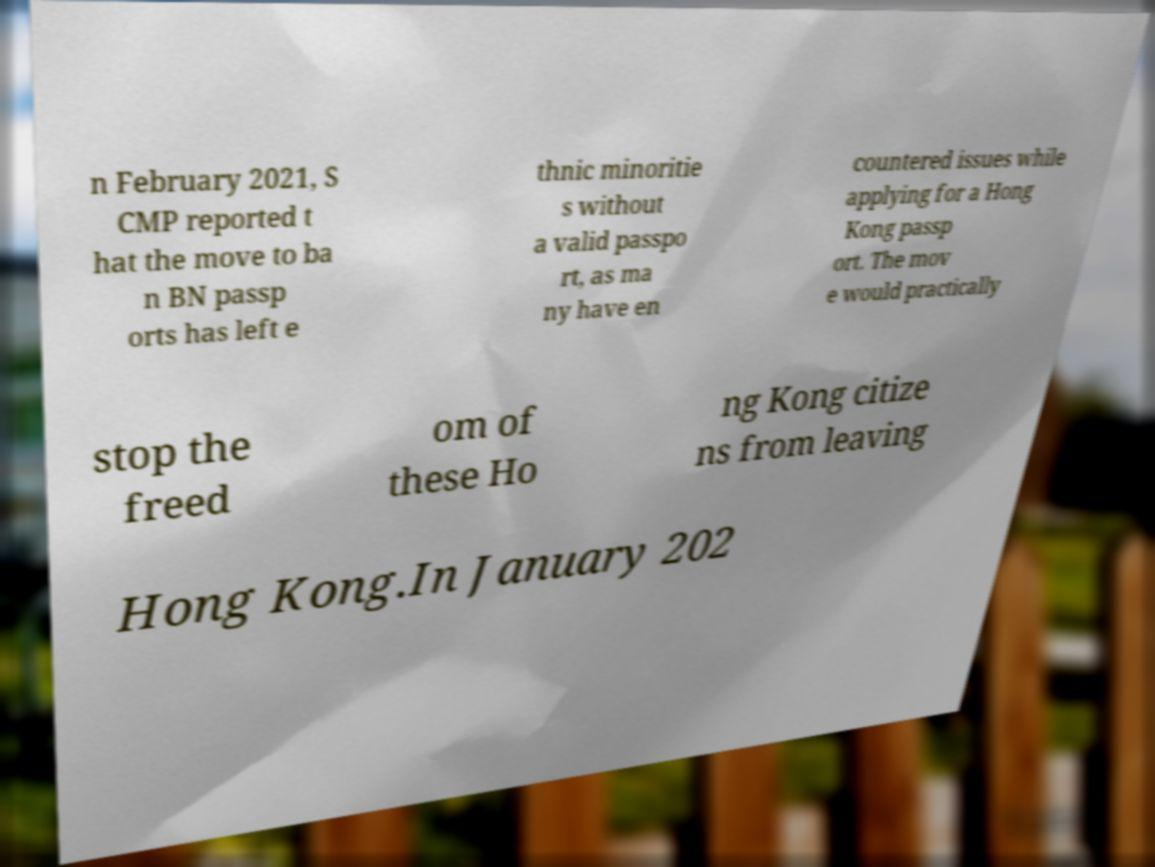Please identify and transcribe the text found in this image. n February 2021, S CMP reported t hat the move to ba n BN passp orts has left e thnic minoritie s without a valid passpo rt, as ma ny have en countered issues while applying for a Hong Kong passp ort. The mov e would practically stop the freed om of these Ho ng Kong citize ns from leaving Hong Kong.In January 202 